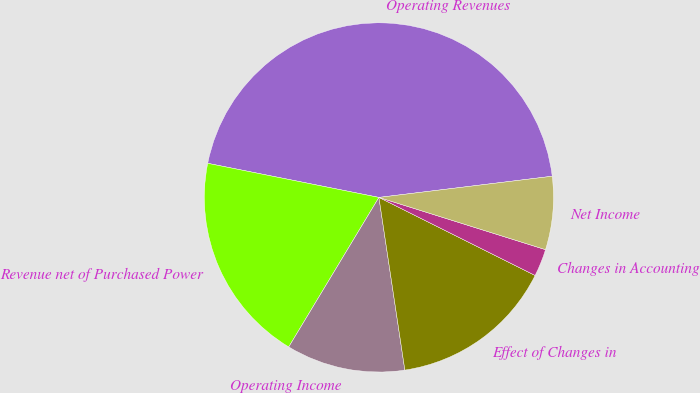Convert chart. <chart><loc_0><loc_0><loc_500><loc_500><pie_chart><fcel>Operating Revenues<fcel>Revenue net of Purchased Power<fcel>Operating Income<fcel>Effect of Changes in<fcel>Changes in Accounting<fcel>Net Income<nl><fcel>44.93%<fcel>19.49%<fcel>11.01%<fcel>15.25%<fcel>2.54%<fcel>6.77%<nl></chart> 